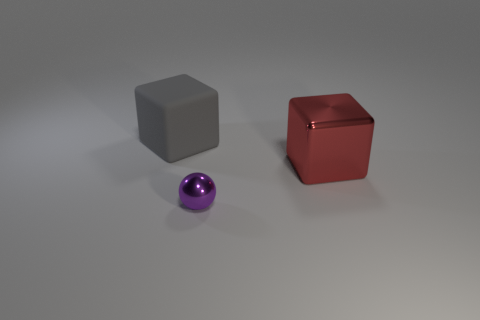Is there any other thing that has the same size as the purple metallic sphere?
Provide a succinct answer. No. What number of other objects are the same shape as the tiny thing?
Ensure brevity in your answer.  0. Does the thing to the left of the purple shiny thing have the same shape as the small object?
Offer a very short reply. No. How many gray blocks are the same size as the red metallic object?
Offer a terse response. 1. Are there any cubes that are behind the cube in front of the gray cube?
Provide a succinct answer. Yes. How many things are things to the right of the sphere or tiny cyan cylinders?
Keep it short and to the point. 1. What number of gray rubber things are there?
Offer a very short reply. 1. What shape is the tiny purple thing that is the same material as the big red object?
Keep it short and to the point. Sphere. There is a metallic object that is on the left side of the shiny object that is behind the tiny shiny ball; what is its size?
Ensure brevity in your answer.  Small. What number of things are either objects left of the red shiny thing or large blocks that are in front of the large gray rubber object?
Ensure brevity in your answer.  3. 